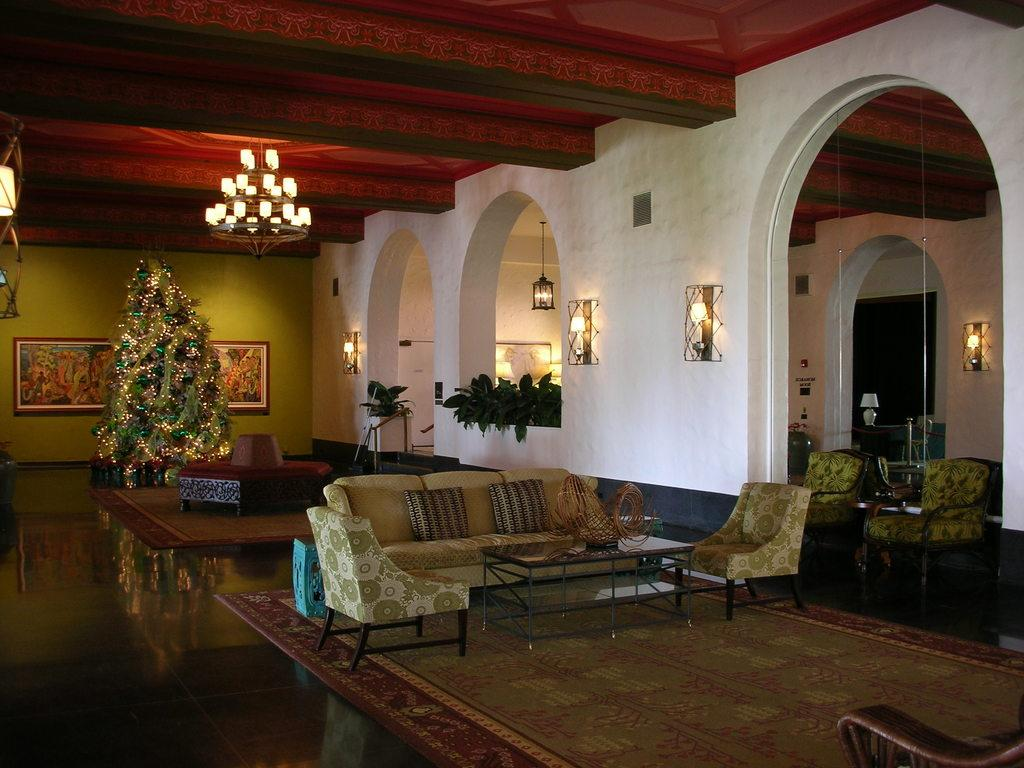What type of objects can be found in the room? There are plants, sofas, a Christmas tree, a lamp, and floor mats in the room. Can you describe the furniture in the room? There are sofas in the room. Where is the Christmas tree located in the room? The Christmas tree is in the corner of the room. What is the purpose of the lamp in the room? The lamp is on the roof, likely providing light. What type of camera can be seen on the floor mats in the image? There is no camera present on the floor mats in the image. What color is the underwear hanging from the Christmas tree? There is no underwear present on the Christmas tree in the image. 